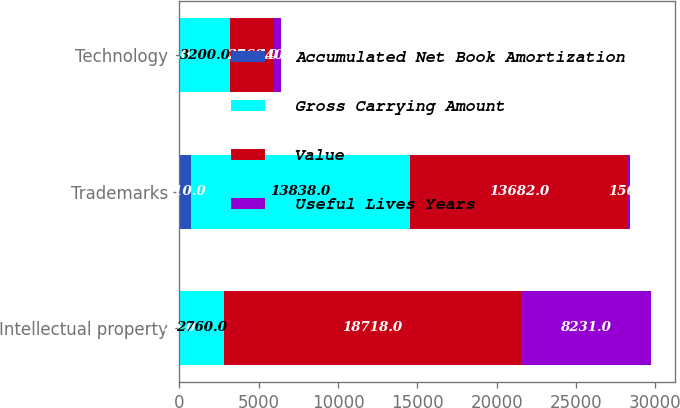Convert chart to OTSL. <chart><loc_0><loc_0><loc_500><loc_500><stacked_bar_chart><ecel><fcel>Intellectual property<fcel>Trademarks<fcel>Technology<nl><fcel>Accumulated Net Book Amortization<fcel>26<fcel>710<fcel>3<nl><fcel>Gross Carrying Amount<fcel>2760<fcel>13838<fcel>3200<nl><fcel>Value<fcel>18718<fcel>13682<fcel>2760<nl><fcel>Useful Lives Years<fcel>8231<fcel>156<fcel>440<nl></chart> 